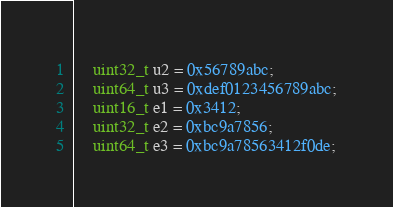Convert code to text. <code><loc_0><loc_0><loc_500><loc_500><_C++_>	uint32_t u2 = 0x56789abc;
	uint64_t u3 = 0xdef0123456789abc;
	uint16_t e1 = 0x3412;
	uint32_t e2 = 0xbc9a7856;
	uint64_t e3 = 0xbc9a78563412f0de;</code> 